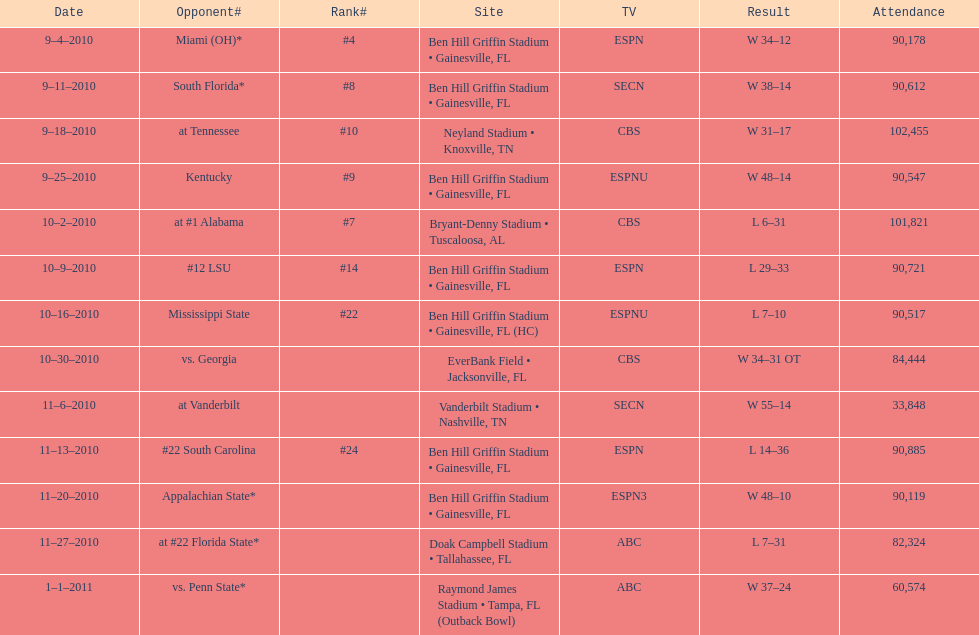What was the difference between the two scores of the last game? 13 points. 